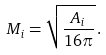<formula> <loc_0><loc_0><loc_500><loc_500>M _ { i } = \sqrt { \frac { A _ { i } } { 1 6 \pi } } \, .</formula> 